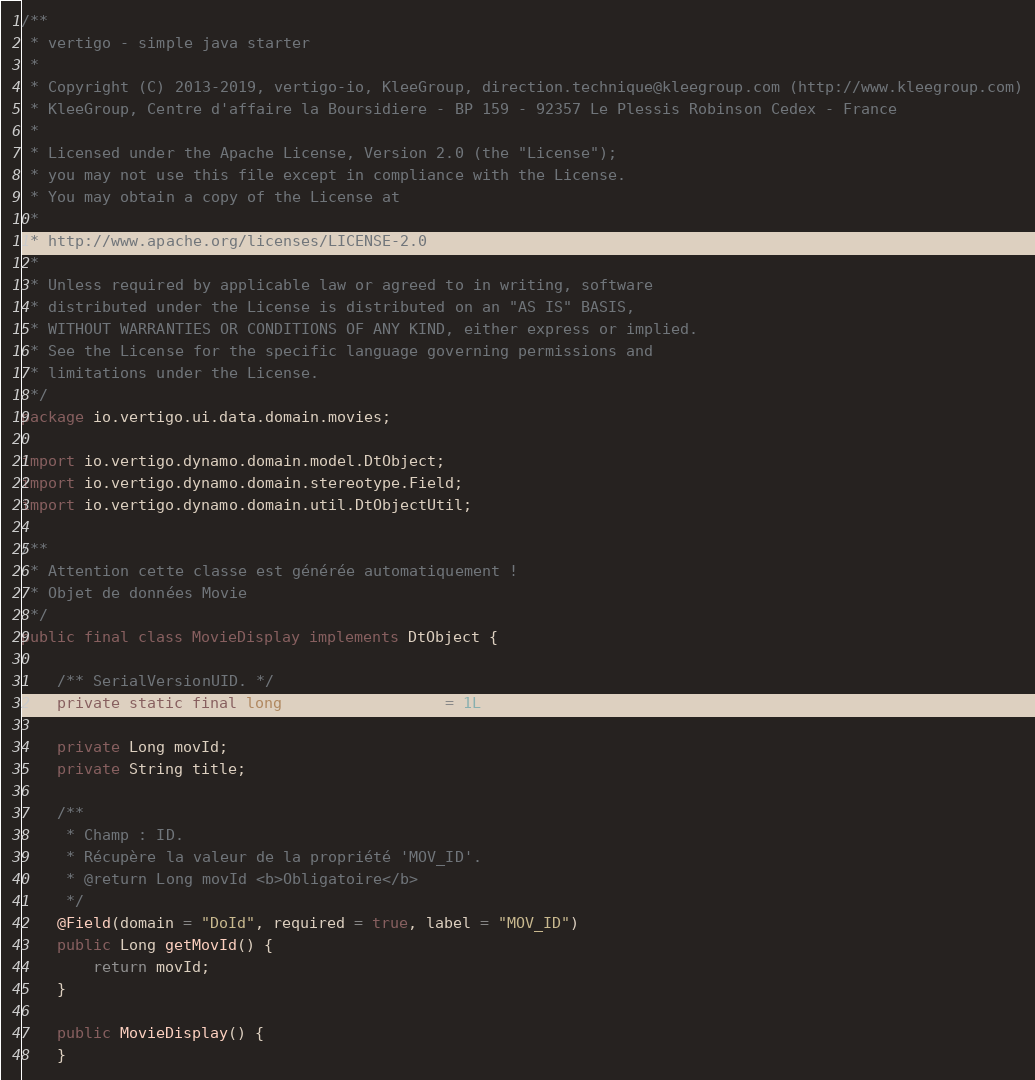<code> <loc_0><loc_0><loc_500><loc_500><_Java_>/**
 * vertigo - simple java starter
 *
 * Copyright (C) 2013-2019, vertigo-io, KleeGroup, direction.technique@kleegroup.com (http://www.kleegroup.com)
 * KleeGroup, Centre d'affaire la Boursidiere - BP 159 - 92357 Le Plessis Robinson Cedex - France
 *
 * Licensed under the Apache License, Version 2.0 (the "License");
 * you may not use this file except in compliance with the License.
 * You may obtain a copy of the License at
 *
 * http://www.apache.org/licenses/LICENSE-2.0
 *
 * Unless required by applicable law or agreed to in writing, software
 * distributed under the License is distributed on an "AS IS" BASIS,
 * WITHOUT WARRANTIES OR CONDITIONS OF ANY KIND, either express or implied.
 * See the License for the specific language governing permissions and
 * limitations under the License.
 */
package io.vertigo.ui.data.domain.movies;

import io.vertigo.dynamo.domain.model.DtObject;
import io.vertigo.dynamo.domain.stereotype.Field;
import io.vertigo.dynamo.domain.util.DtObjectUtil;

/**
 * Attention cette classe est générée automatiquement !
 * Objet de données Movie
 */
public final class MovieDisplay implements DtObject {

	/** SerialVersionUID. */
	private static final long serialVersionUID = 1L;

	private Long movId;
	private String title;

	/**
	 * Champ : ID.
	 * Récupère la valeur de la propriété 'MOV_ID'.
	 * @return Long movId <b>Obligatoire</b>
	 */
	@Field(domain = "DoId", required = true, label = "MOV_ID")
	public Long getMovId() {
		return movId;
	}

	public MovieDisplay() {
	}
</code> 